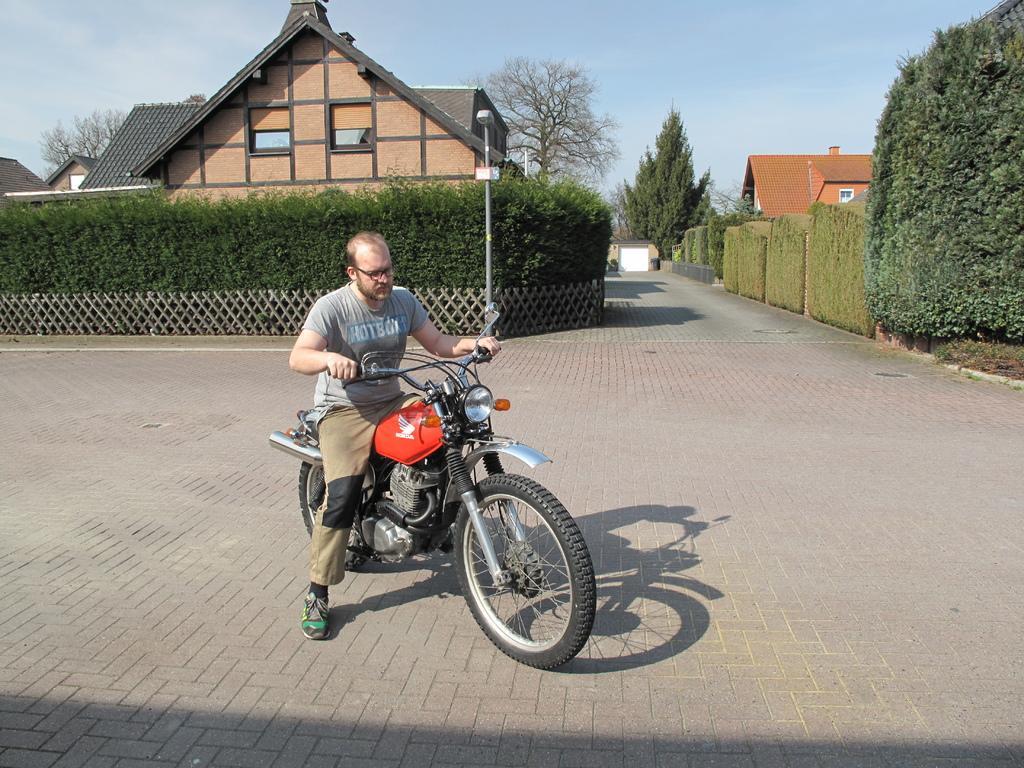In one or two sentences, can you explain what this image depicts? A man is riding a bike in street. There some plants on either side of the lane. There is street light at a distance and houses. Sky is looking clear. 